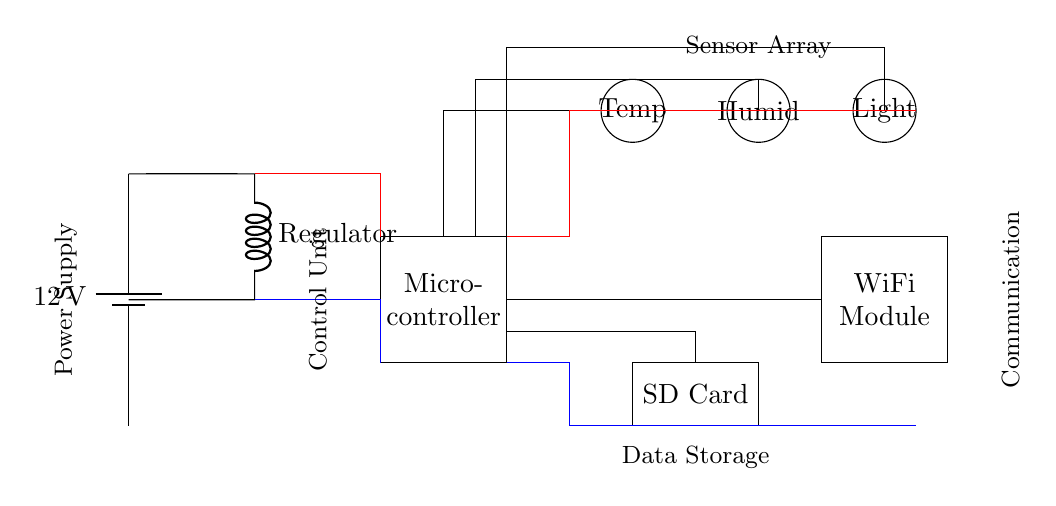What is the voltage of the power supply? The voltage is twelve volts, which is indicated clearly on the battery in the circuit diagram.
Answer: twelve volts What is the purpose of the microcontroller in this circuit? The microcontroller acts as the control unit, processing data from the sensors and managing the communication with the WiFi module and storage.
Answer: control unit How many sensors are connected to the microcontroller? There are three sensors connected to the microcontroller, which include temperature, humidity, and light sensors.
Answer: three What type of data storage is used in this system? The data storage component is an SD card, designated clearly in the diagram with a rectangular shape labeled "SD Card."
Answer: SD card Why is a voltage regulator used in this circuit? A voltage regulator is necessary to ensure that the voltage supplied to the microcontroller and other components is stable and within their operating limits, even if the input voltage from the battery fluctuates.
Answer: stability What is the function of the WiFi module? The WiFi module is responsible for enabling wireless communication, allowing the environmental data collected by the sensors to be transmitted to external devices or systems.
Answer: wireless communication From where does the power supply get its voltage? The power supply derives its voltage from the battery connected at the beginning of the circuit diagram, which is specified as twelve volts.
Answer: battery 